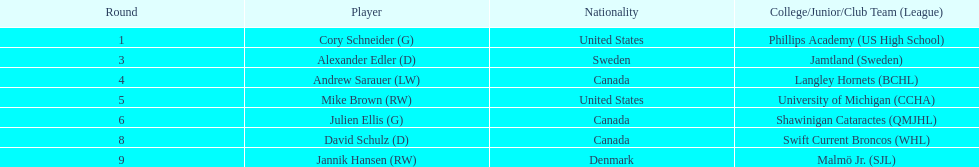What is the number of goalkeepers selected in the draft? 2. 